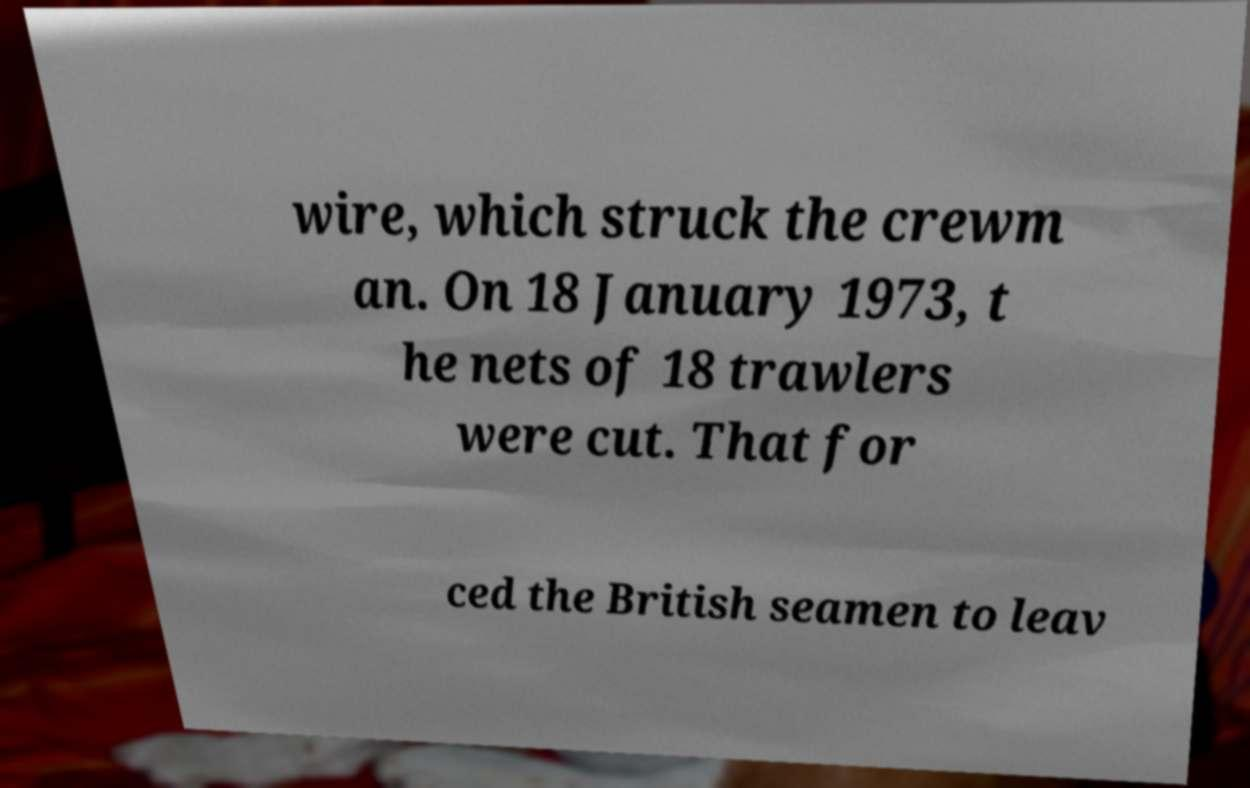There's text embedded in this image that I need extracted. Can you transcribe it verbatim? wire, which struck the crewm an. On 18 January 1973, t he nets of 18 trawlers were cut. That for ced the British seamen to leav 